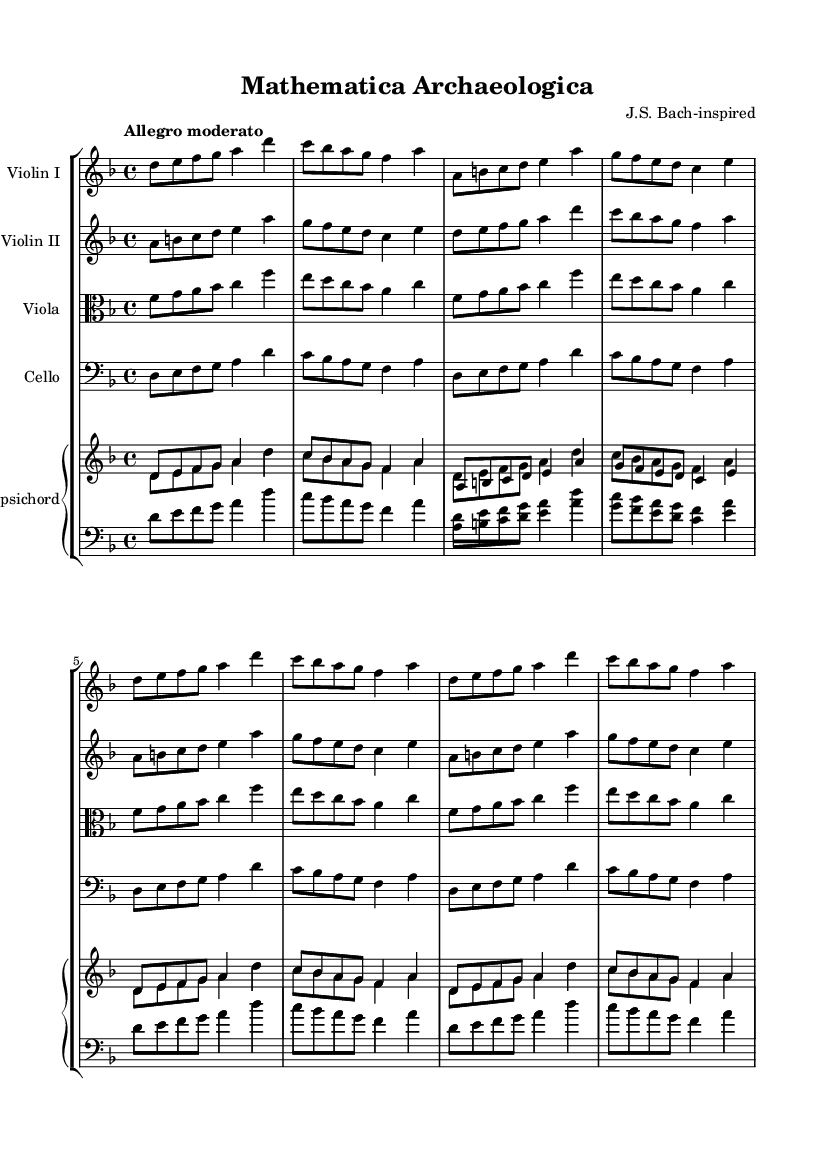What is the key signature of this music? The key signature is indicated at the beginning of the staff. In this case, it shows one flat (B♭), which identifies the key as D minor.
Answer: D minor What is the time signature of this music? The time signature is displayed at the beginning of the score after the key signature. Here, it is indicated as 4/4, which means there are four beats per measure and the quarter note gets one beat.
Answer: 4/4 What is the tempo marking for this piece? The tempo marking is shown at the start of the score, reading "Allegro moderato." This indicates a moderate fast pace, typical for lively Baroque music.
Answer: Allegro moderato How many repetitions of the section are indicated for the violin parts? The violin parts contain a "repeat unfold" directive, which indicates that the specific section is to be played twice. This is evidenced in the part of the score following that phrase.
Answer: 2 Which instruments are included in this ensemble? The ensemble consists of strings and harpsichord, as denoted by the respective instrument names at the start of each staff. The list includes Violin I, Violin II, Viola, Cello, and Harpsichord.
Answer: Violin I, Violin II, Viola, Cello, Harpsichord What harmonic structure does this music utilize? The music employs counterpoint, where more than one melodic line is played simultaneously. This is evident as each instrument plays independent yet harmonious lines, typical of Baroque music.
Answer: Counterpoint 